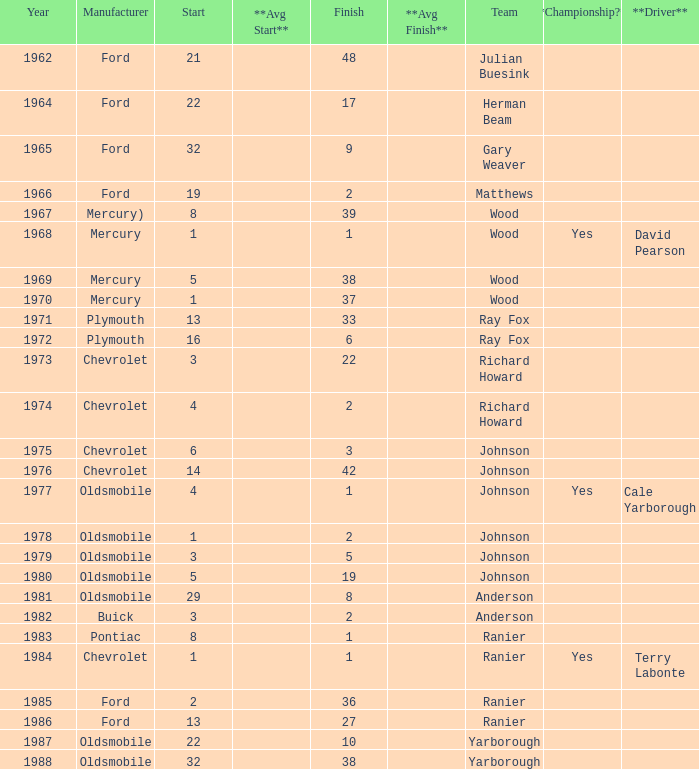Who was the maufacturer of the vehicle during the race where Cale Yarborough started at 19 and finished earlier than 42? Ford. 